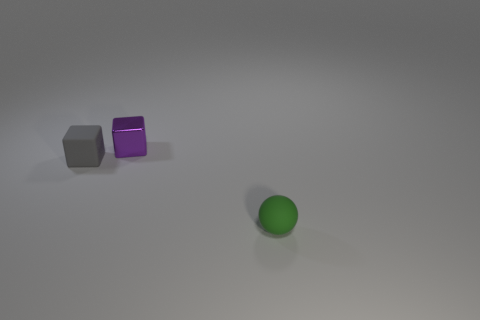Add 1 brown cylinders. How many objects exist? 4 Add 1 gray matte things. How many gray matte things are left? 2 Add 3 small purple things. How many small purple things exist? 4 Subtract 0 gray spheres. How many objects are left? 3 Subtract all balls. How many objects are left? 2 Subtract 2 cubes. How many cubes are left? 0 Subtract all blue blocks. Subtract all red balls. How many blocks are left? 2 Subtract all green spheres. How many gray cubes are left? 1 Subtract all small blue balls. Subtract all metallic things. How many objects are left? 2 